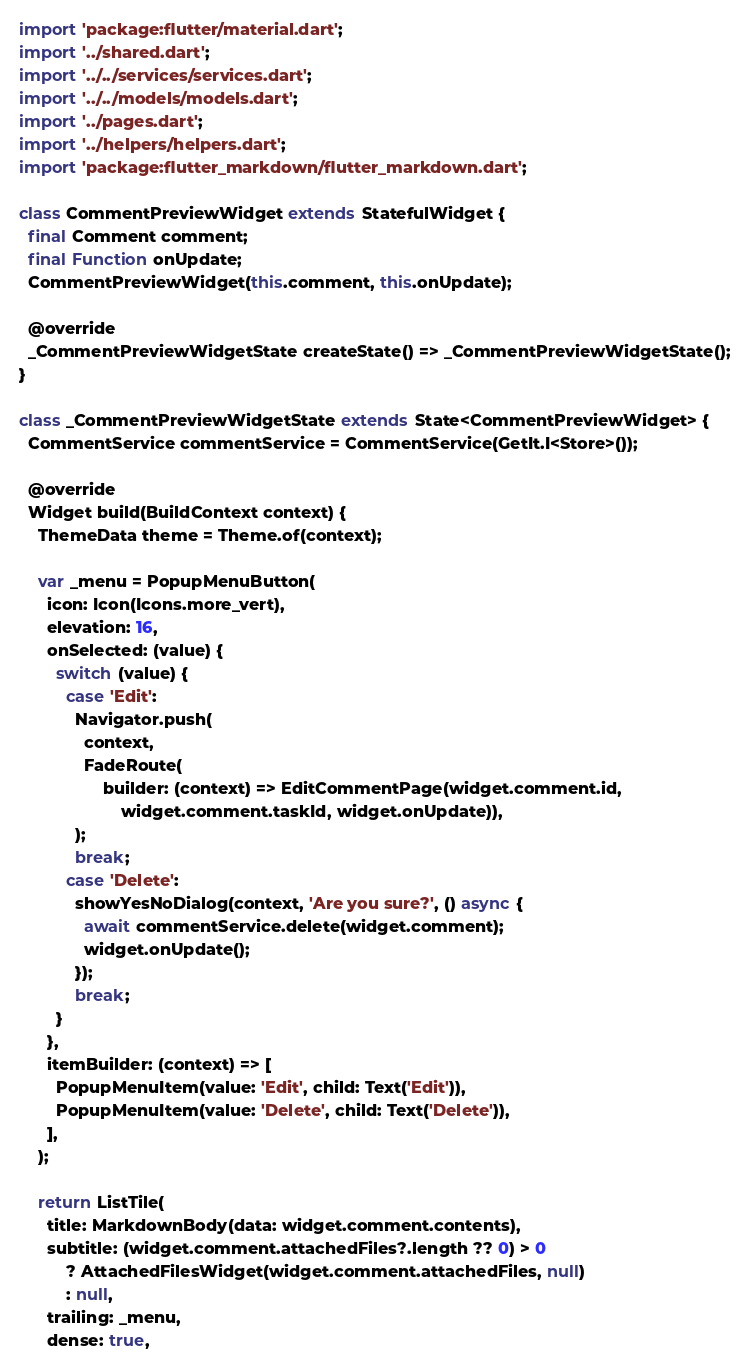<code> <loc_0><loc_0><loc_500><loc_500><_Dart_>import 'package:flutter/material.dart';
import '../shared.dart';
import '../../services/services.dart';
import '../../models/models.dart';
import '../pages.dart';
import '../helpers/helpers.dart';
import 'package:flutter_markdown/flutter_markdown.dart';

class CommentPreviewWidget extends StatefulWidget {
  final Comment comment;
  final Function onUpdate;
  CommentPreviewWidget(this.comment, this.onUpdate);

  @override
  _CommentPreviewWidgetState createState() => _CommentPreviewWidgetState();
}

class _CommentPreviewWidgetState extends State<CommentPreviewWidget> {
  CommentService commentService = CommentService(GetIt.I<Store>());

  @override
  Widget build(BuildContext context) {
    ThemeData theme = Theme.of(context);

    var _menu = PopupMenuButton(
      icon: Icon(Icons.more_vert),
      elevation: 16,
      onSelected: (value) {
        switch (value) {
          case 'Edit':
            Navigator.push(
              context,
              FadeRoute(
                  builder: (context) => EditCommentPage(widget.comment.id,
                      widget.comment.taskId, widget.onUpdate)),
            );
            break;
          case 'Delete':
            showYesNoDialog(context, 'Are you sure?', () async {
              await commentService.delete(widget.comment);
              widget.onUpdate();
            });
            break;
        }
      },
      itemBuilder: (context) => [
        PopupMenuItem(value: 'Edit', child: Text('Edit')),
        PopupMenuItem(value: 'Delete', child: Text('Delete')),
      ],
    );

    return ListTile(
      title: MarkdownBody(data: widget.comment.contents),
      subtitle: (widget.comment.attachedFiles?.length ?? 0) > 0
          ? AttachedFilesWidget(widget.comment.attachedFiles, null)
          : null,
      trailing: _menu,
      dense: true,</code> 